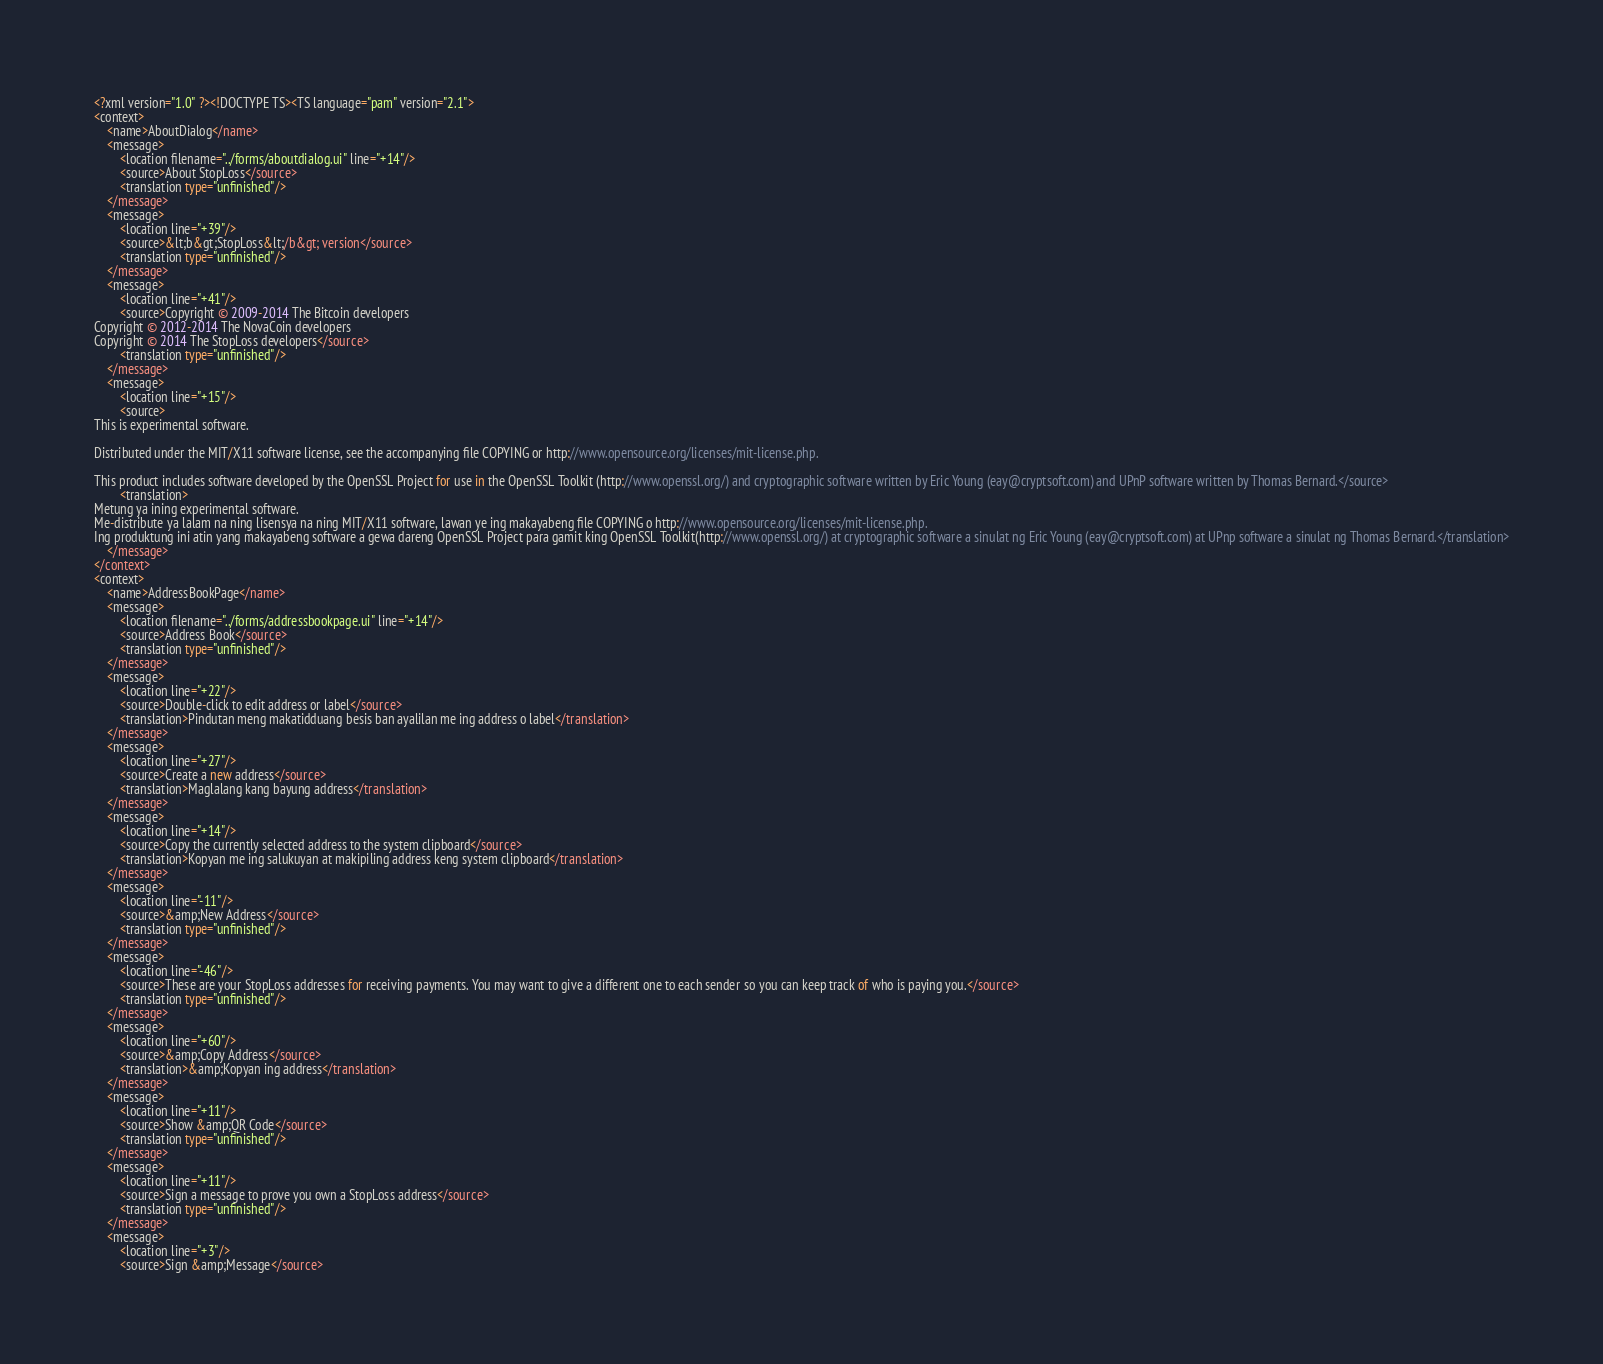<code> <loc_0><loc_0><loc_500><loc_500><_TypeScript_><?xml version="1.0" ?><!DOCTYPE TS><TS language="pam" version="2.1">
<context>
    <name>AboutDialog</name>
    <message>
        <location filename="../forms/aboutdialog.ui" line="+14"/>
        <source>About StopLoss</source>
        <translation type="unfinished"/>
    </message>
    <message>
        <location line="+39"/>
        <source>&lt;b&gt;StopLoss&lt;/b&gt; version</source>
        <translation type="unfinished"/>
    </message>
    <message>
        <location line="+41"/>
        <source>Copyright © 2009-2014 The Bitcoin developers
Copyright © 2012-2014 The NovaCoin developers
Copyright © 2014 The StopLoss developers</source>
        <translation type="unfinished"/>
    </message>
    <message>
        <location line="+15"/>
        <source>
This is experimental software.

Distributed under the MIT/X11 software license, see the accompanying file COPYING or http://www.opensource.org/licenses/mit-license.php.

This product includes software developed by the OpenSSL Project for use in the OpenSSL Toolkit (http://www.openssl.org/) and cryptographic software written by Eric Young (eay@cryptsoft.com) and UPnP software written by Thomas Bernard.</source>
        <translation>
Metung ya ining experimental software.
Me-distribute ya lalam na ning lisensya na ning MIT/X11 software, lawan ye ing makayabeng file COPYING o http://www.opensource.org/licenses/mit-license.php.
Ing produktung ini atin yang makayabeng software a gewa dareng OpenSSL Project para gamit king OpenSSL Toolkit(http://www.openssl.org/) at cryptographic software a sinulat ng Eric Young (eay@cryptsoft.com) at UPnp software a sinulat ng Thomas Bernard.</translation>
    </message>
</context>
<context>
    <name>AddressBookPage</name>
    <message>
        <location filename="../forms/addressbookpage.ui" line="+14"/>
        <source>Address Book</source>
        <translation type="unfinished"/>
    </message>
    <message>
        <location line="+22"/>
        <source>Double-click to edit address or label</source>
        <translation>Pindutan meng makatidduang besis ban ayalilan me ing address o label</translation>
    </message>
    <message>
        <location line="+27"/>
        <source>Create a new address</source>
        <translation>Maglalang kang bayung address</translation>
    </message>
    <message>
        <location line="+14"/>
        <source>Copy the currently selected address to the system clipboard</source>
        <translation>Kopyan me ing salukuyan at makipiling address keng system clipboard</translation>
    </message>
    <message>
        <location line="-11"/>
        <source>&amp;New Address</source>
        <translation type="unfinished"/>
    </message>
    <message>
        <location line="-46"/>
        <source>These are your StopLoss addresses for receiving payments. You may want to give a different one to each sender so you can keep track of who is paying you.</source>
        <translation type="unfinished"/>
    </message>
    <message>
        <location line="+60"/>
        <source>&amp;Copy Address</source>
        <translation>&amp;Kopyan ing address</translation>
    </message>
    <message>
        <location line="+11"/>
        <source>Show &amp;QR Code</source>
        <translation type="unfinished"/>
    </message>
    <message>
        <location line="+11"/>
        <source>Sign a message to prove you own a StopLoss address</source>
        <translation type="unfinished"/>
    </message>
    <message>
        <location line="+3"/>
        <source>Sign &amp;Message</source></code> 